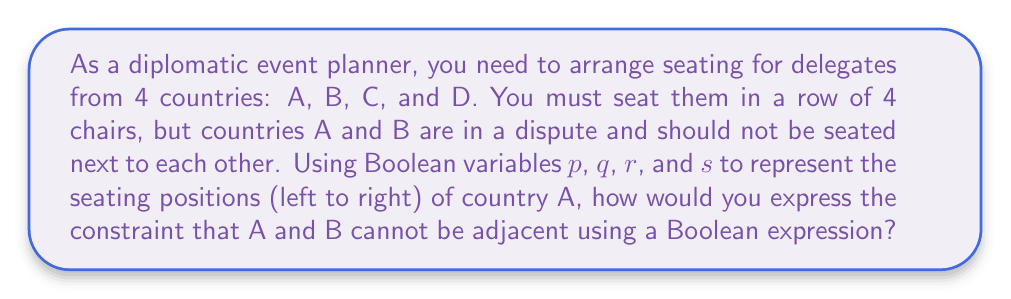Help me with this question. Let's approach this step-by-step:

1) We define Boolean variables for country A's seating:
   $p$: A is in the first seat
   $q$: A is in the second seat
   $r$: A is in the third seat
   $s$: A is in the fourth seat

2) For A and B to not be adjacent, we need to consider all possible scenarios where they could be adjacent and negate them:

   a) If A is in the first seat ($p$), B cannot be in the second seat.
   b) If A is in the second seat ($q$), B cannot be in the first or third seat.
   c) If A is in the third seat ($r$), B cannot be in the second or fourth seat.
   d) If A is in the fourth seat ($s$), B cannot be in the third seat.

3) We can express this using the following Boolean expression:

   $$(\neg p \lor \neg B_2) \land (\neg q \lor (\neg B_1 \land \neg B_3)) \land (\neg r \lor (\neg B_2 \land \neg B_4)) \land (\neg s \lor \neg B_3)$$

   Where $B_1$, $B_2$, $B_3$, and $B_4$ represent B being in the first, second, third, and fourth seats respectively.

4) However, we can simplify this expression by noting that B must be in one of the seats not occupied by A. So, we can express the constraint more concisely as:

   $$(\neg p \lor \neg q) \land (\neg q \lor \neg r) \land (\neg r \lor \neg s)$$

This expression ensures that A is not in two adjacent seats, which implicitly guarantees that B cannot be next to A.
Answer: $$(\neg p \lor \neg q) \land (\neg q \lor \neg r) \land (\neg r \lor \neg s)$$ 